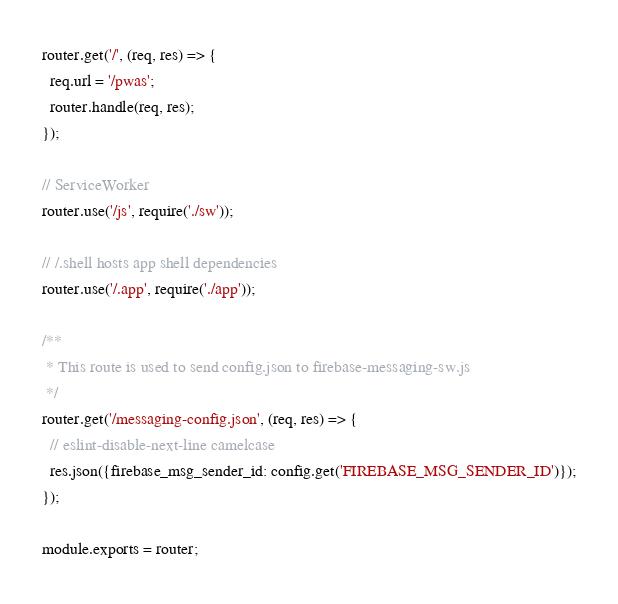Convert code to text. <code><loc_0><loc_0><loc_500><loc_500><_JavaScript_>
router.get('/', (req, res) => {
  req.url = '/pwas';
  router.handle(req, res);
});

// ServiceWorker
router.use('/js', require('./sw'));

// /.shell hosts app shell dependencies
router.use('/.app', require('./app'));

/**
 * This route is used to send config.json to firebase-messaging-sw.js
 */
router.get('/messaging-config.json', (req, res) => {
  // eslint-disable-next-line camelcase
  res.json({firebase_msg_sender_id: config.get('FIREBASE_MSG_SENDER_ID')});
});

module.exports = router;
</code> 